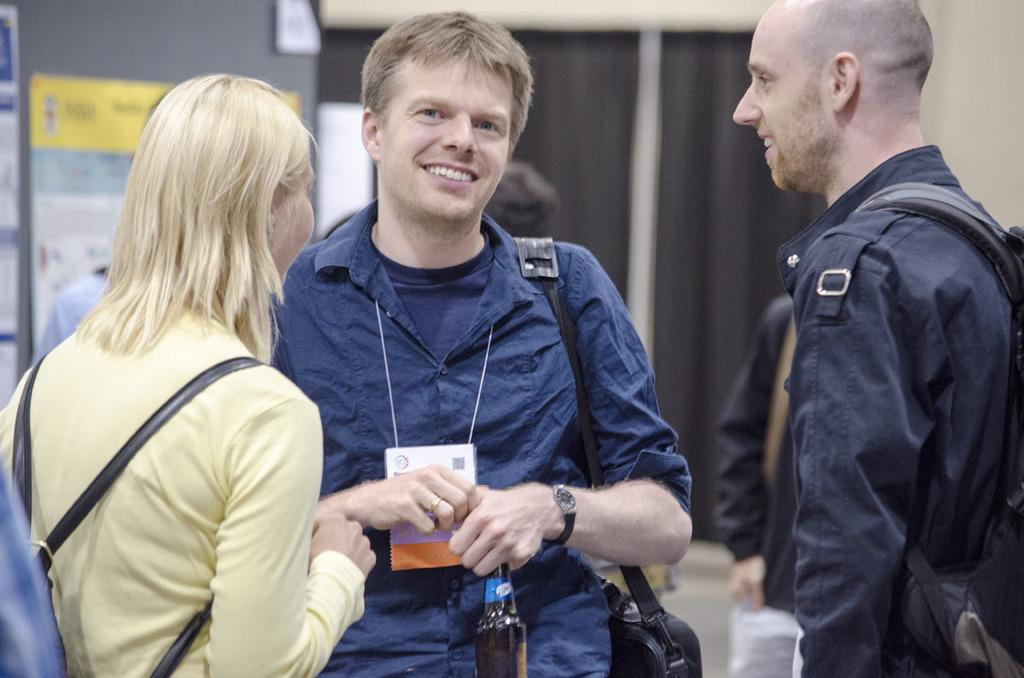How many people are in the foreground of the picture? There are three persons standing in the foreground of the picture. Can you describe the background of the picture? The background is blurred, and there are curtains, a wall, a board, a poster, and other objects visible. What is the purpose of the board in the background? The facts provided do not specify the purpose of the board in the background. What type of objects are present in the background? The background contains a variety of objects, including curtains, a wall, a board, a poster, and other unspecified objects. What is the rate of the sack in the image? There is no sack present in the image, so it is not possible to determine a rate for it. 